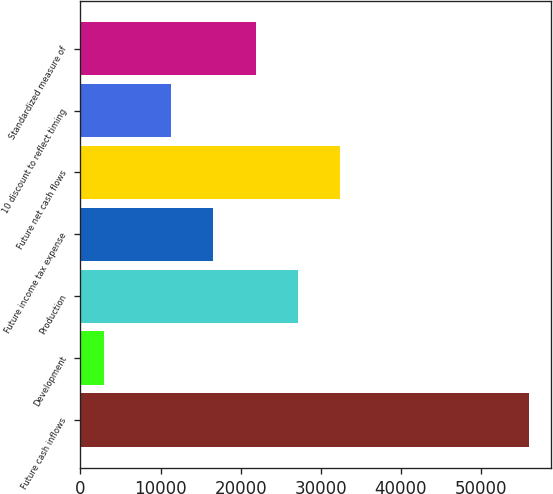<chart> <loc_0><loc_0><loc_500><loc_500><bar_chart><fcel>Future cash inflows<fcel>Development<fcel>Production<fcel>Future income tax expense<fcel>Future net cash flows<fcel>10 discount to reflect timing<fcel>Standardized measure of<nl><fcel>55954<fcel>2954<fcel>27158<fcel>16558<fcel>32458<fcel>11258<fcel>21858<nl></chart> 